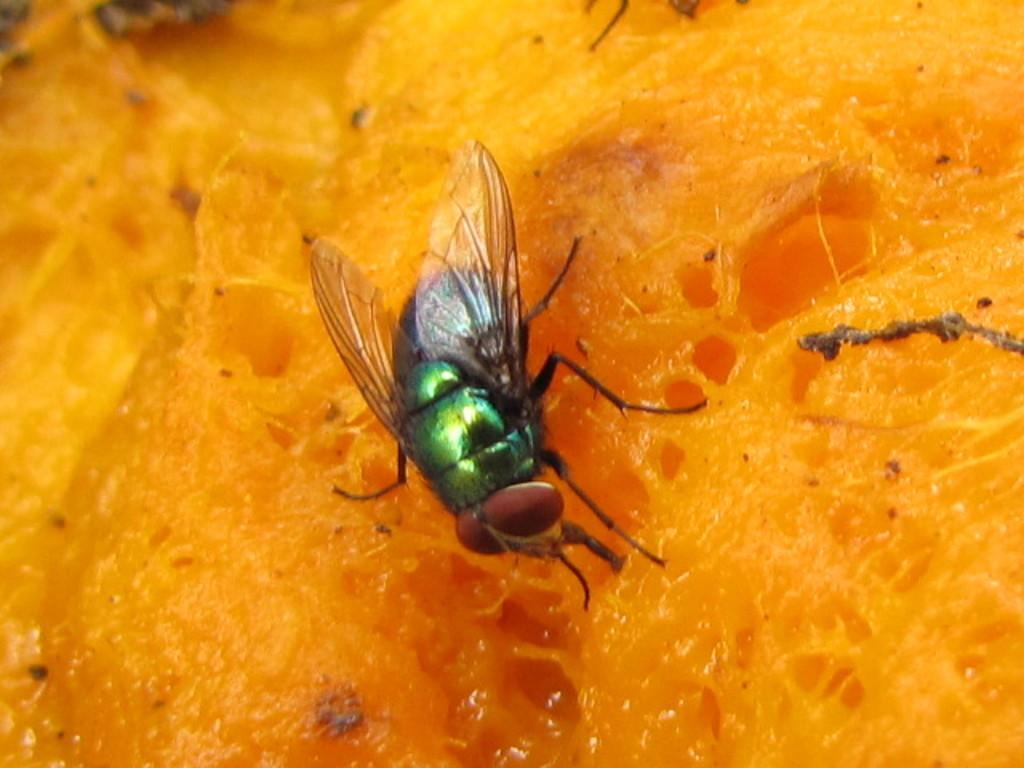What type of insect is present in the image? There is a fly in the image. What type of health benefits can be gained from eating the cabbage in the image? There is no cabbage present in the image, so it is not possible to discuss any health benefits related to it. 